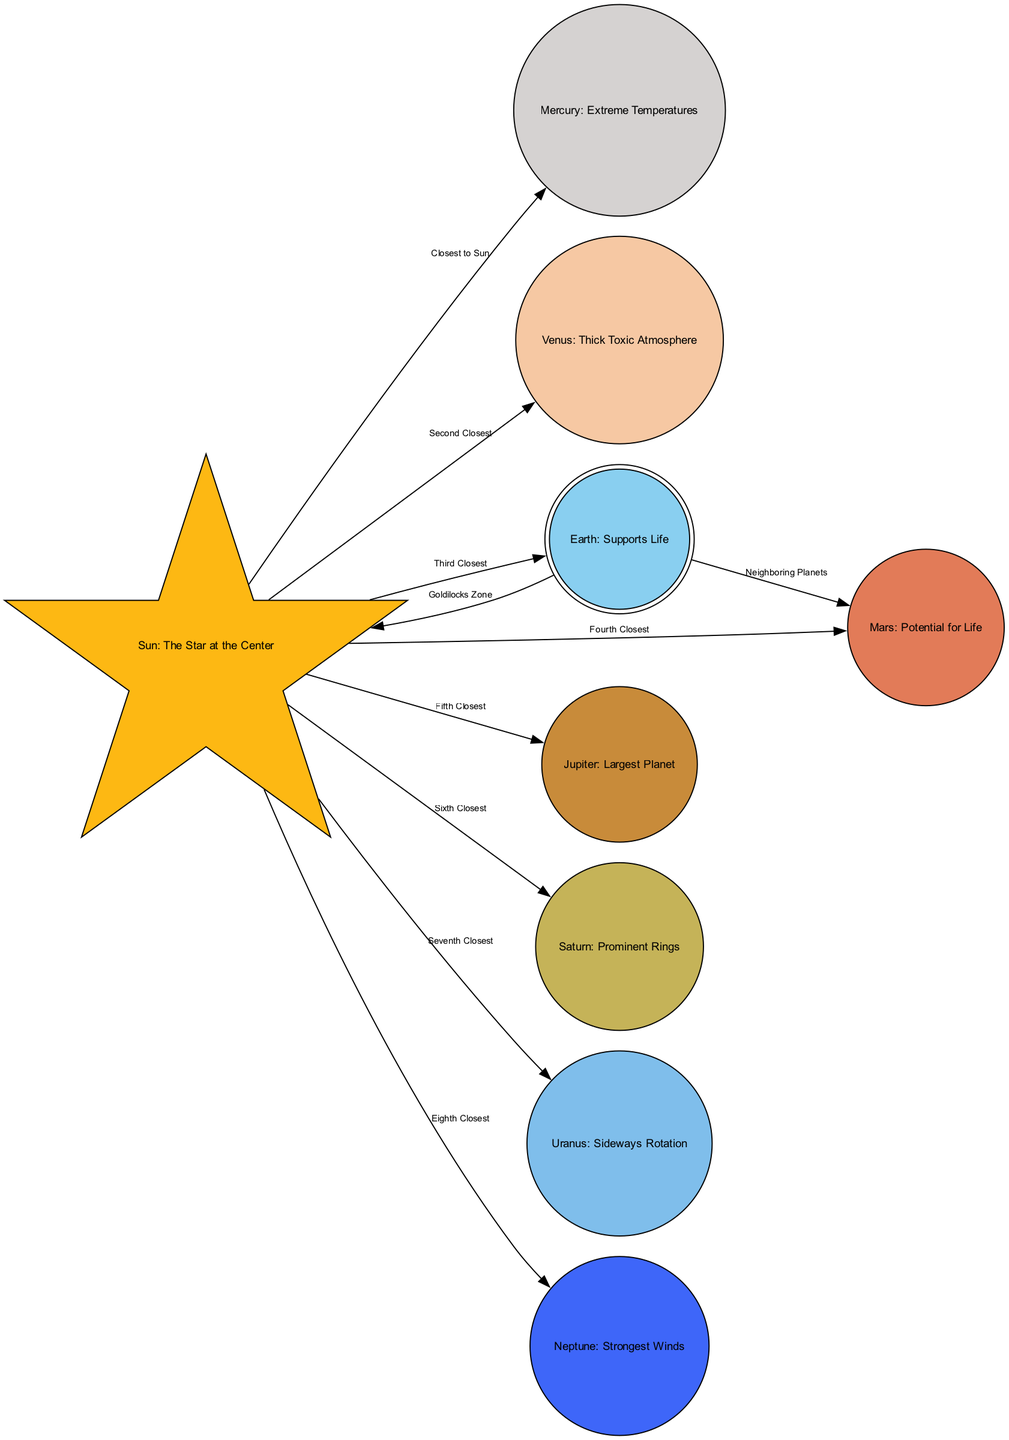What planet is closest to the Sun? The diagram indicates that Mercury is directly connected to the Sun with the label "Closest to Sun." This connection shows that Mercury is the nearest planet to the Sun in our solar system.
Answer: Mercury How many planets are listed in the diagram? The diagram includes a total of 8 nodes representing planets (Mercury, Venus, Earth, Mars, Jupiter, Saturn, Uranus, and Neptune). Counting these nodes gives us the total number of planets.
Answer: 8 Which planet has extreme temperatures? The node labeled "Mercury" has the description "Extreme Temperatures," indicating that this planet is known for its severe temperature variations.
Answer: Mercury What unique feature is associated with Mars? The description for Mars in the diagram is "Potential for Life," which highlights this planet's unique characteristic related to the possibility of life existing there.
Answer: Potential for Life Which planet has the thick toxic atmosphere? The node labeled "Venus" contains the feature "Thick Toxic Atmosphere," indicating that Venus is known for having a dense and harmful atmosphere.
Answer: Thick Toxic Atmosphere What is the relationship between Earth and Mars in the diagram? The edges display that Earth is a neighboring planet to Mars with the label "Neighboring Planets," meaning they are positioned close to one another within the solar system.
Answer: Neighboring Planets Which planet is described as having the strongest winds? The node for Neptune states "Strongest Winds," identifying this planet as the one with the most powerful wind conditions in the solar system.
Answer: Strongest Winds What is the unique characteristic of Jupiter presented in the diagram? The node for Jupiter is labeled "Largest Planet," indicating that Jupiter is recognized for being the biggest planet in our solar system.
Answer: Largest Planet How many planets have a direct connection to the Sun? The diagram shows that all 8 planets listed have direct connections to the Sun, evidenced by the edges pointing from the Sun to each of the planets.
Answer: 8 